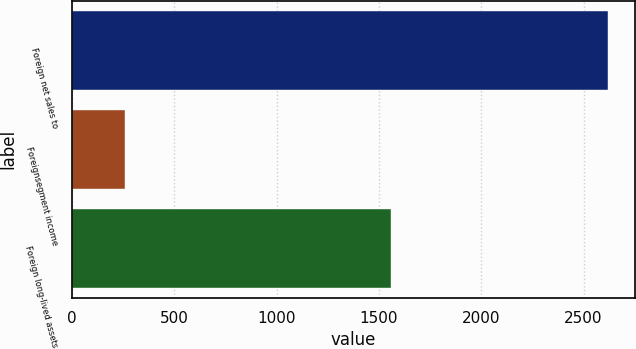Convert chart to OTSL. <chart><loc_0><loc_0><loc_500><loc_500><bar_chart><fcel>Foreign net sales to<fcel>Foreignsegment income<fcel>Foreign long-lived assets<nl><fcel>2621.2<fcel>260.1<fcel>1558.3<nl></chart> 